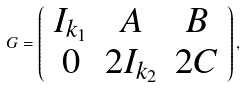<formula> <loc_0><loc_0><loc_500><loc_500>G = \left ( \begin{array} { c c c } I _ { k _ { 1 } } & A & B \\ 0 & 2 I _ { k _ { 2 } } & 2 C \\ \end{array} \right ) ,</formula> 